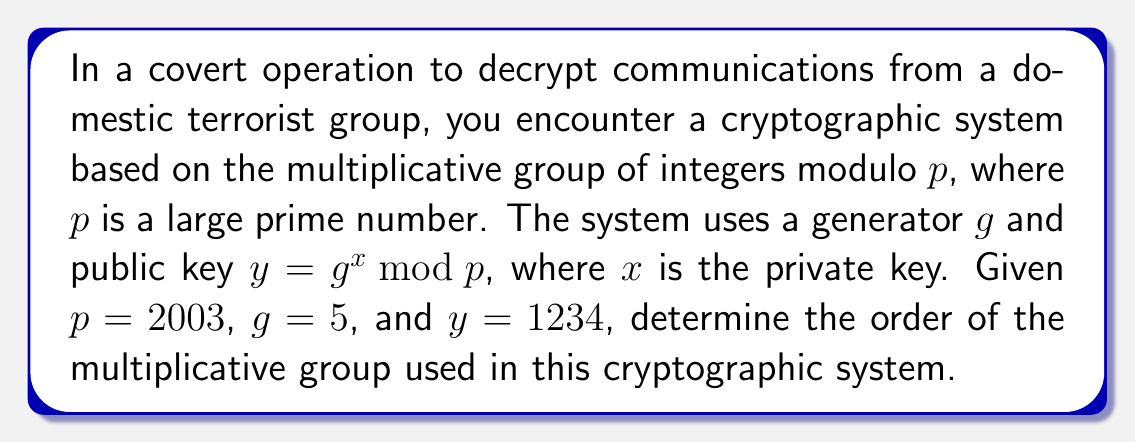Give your solution to this math problem. To determine the order of the multiplicative group of integers modulo $p$, we need to follow these steps:

1) The multiplicative group of integers modulo $p$ is denoted as $(\mathbb{Z}/p\mathbb{Z})^*$.

2) For a prime $p$, the order of $(\mathbb{Z}/p\mathbb{Z})^*$ is always $p - 1$.

3) In this case, $p = 2003$, which is indeed a prime number.

4) Therefore, the order of the group is $2003 - 1 = 2002$.

Note: This result is crucial in cryptography, particularly in systems based on the discrete logarithm problem, such as the ElGamal encryption system or the Diffie-Hellman key exchange. The security of these systems relies on the difficulty of computing discrete logarithms in large groups.

The fact that the order is $2002 = 2 \times 1001$ (product of a small and a large prime) is also significant. In practice, for maximum security, we usually choose $p$ such that $(p-1)/2$ is also prime (called a safe prime), which is not the case here.
Answer: The order of the multiplicative group $(\mathbb{Z}/2003\mathbb{Z})^*$ is $2002$. 